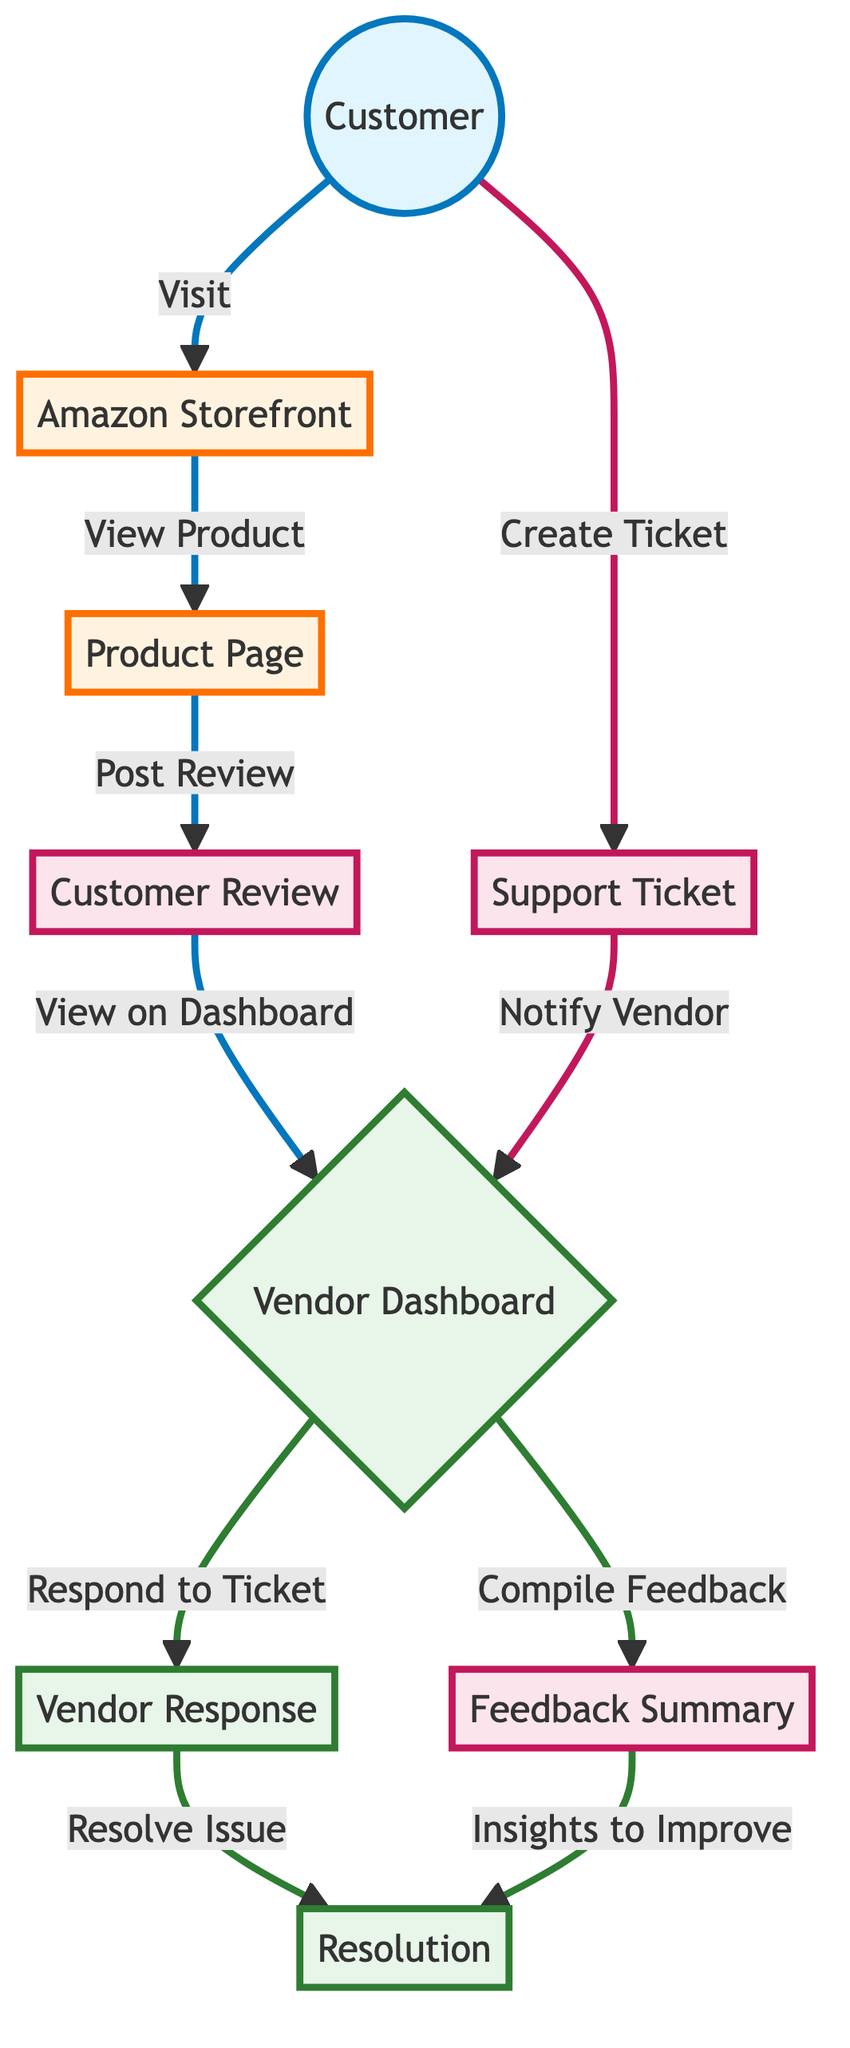What is the total number of nodes in the diagram? The diagram contains the following nodes: Customer, Amazon Storefront, Product Page, Customer Review, Vendor Dashboard, Support Ticket, Vendor Response, Resolution, and Feedback Summary. Counting these, there are a total of 9 nodes.
Answer: 9 How many edges connect the Customer node? The Customer node is connected by two edges: one that leads to the Amazon Storefront and another that leads to the Support Ticket. This gives a total of 2 outgoing edges from the Customer node.
Answer: 2 What label is given to the node that comes after the Vendor Dashboard in the diagram? After the Vendor Dashboard node, there are two paths: one leads to Vendor Response and another to Feedback Summary. However, if we follow the resolution of a support ticket, the first relevant node is Vendor Response.
Answer: Vendor Response Which node does the Customer Review connect to next? The Customer Review node connects to the Vendor Dashboard. This is clearly indicated by the outgoing edge labeled "View on Dashboard."
Answer: Vendor Dashboard Which feedback process leads to insights for improvement? The Feedback Summary node compiles the feedback and connects to the Resolution node, indicating that the insights from the feedback are utilized to improve future services or products.
Answer: Insights to Improve What is the first action a Customer takes in the diagram? The first action a Customer takes is to "Visit" the Amazon Storefront. This is represented by the edge connecting Customer to Amazon Storefront.
Answer: Visit How does a Support Ticket interact with the Vendor Dashboard? The Support Ticket node interacts with the Vendor Dashboard by notifying the vendor after the customer creates a ticket. This relationship is illustrated with the edge labeled "Notify Vendor."
Answer: Notify Vendor What two insights can be gathered from the Vendor Dashboard? From the Vendor Dashboard, the vendor can either respond to a ticket ("Respond to Ticket") or compile feedback ("Compile Feedback"). This indicates that the vendor has multiple avenues for interacting with customer feedback.
Answer: Respond to Ticket and Compile Feedback 